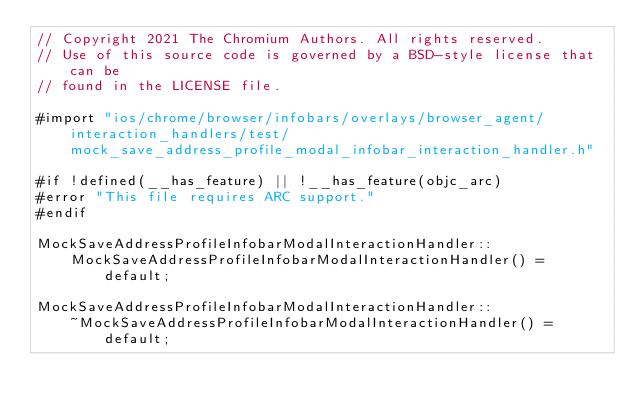Convert code to text. <code><loc_0><loc_0><loc_500><loc_500><_ObjectiveC_>// Copyright 2021 The Chromium Authors. All rights reserved.
// Use of this source code is governed by a BSD-style license that can be
// found in the LICENSE file.

#import "ios/chrome/browser/infobars/overlays/browser_agent/interaction_handlers/test/mock_save_address_profile_modal_infobar_interaction_handler.h"

#if !defined(__has_feature) || !__has_feature(objc_arc)
#error "This file requires ARC support."
#endif

MockSaveAddressProfileInfobarModalInteractionHandler::
    MockSaveAddressProfileInfobarModalInteractionHandler() = default;

MockSaveAddressProfileInfobarModalInteractionHandler::
    ~MockSaveAddressProfileInfobarModalInteractionHandler() = default;
</code> 